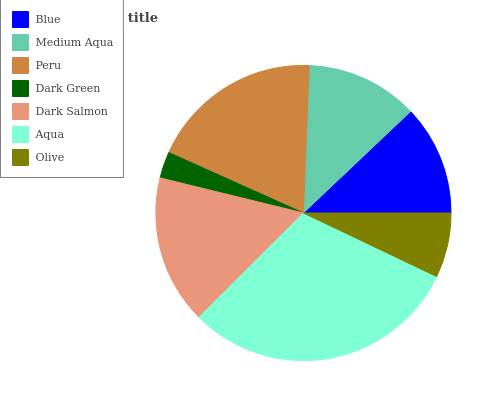Is Dark Green the minimum?
Answer yes or no. Yes. Is Aqua the maximum?
Answer yes or no. Yes. Is Medium Aqua the minimum?
Answer yes or no. No. Is Medium Aqua the maximum?
Answer yes or no. No. Is Medium Aqua greater than Blue?
Answer yes or no. Yes. Is Blue less than Medium Aqua?
Answer yes or no. Yes. Is Blue greater than Medium Aqua?
Answer yes or no. No. Is Medium Aqua less than Blue?
Answer yes or no. No. Is Medium Aqua the high median?
Answer yes or no. Yes. Is Medium Aqua the low median?
Answer yes or no. Yes. Is Blue the high median?
Answer yes or no. No. Is Olive the low median?
Answer yes or no. No. 